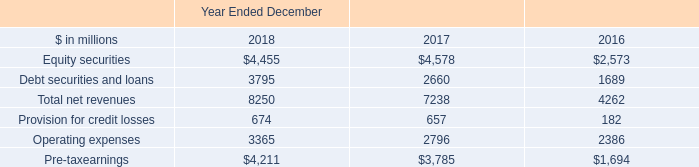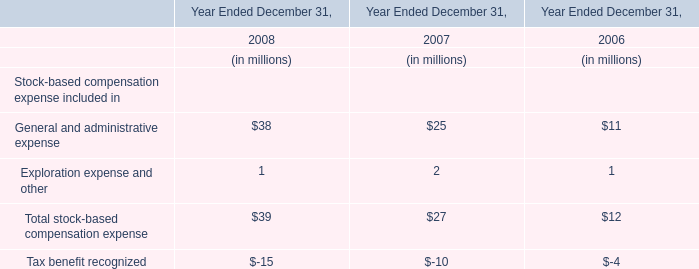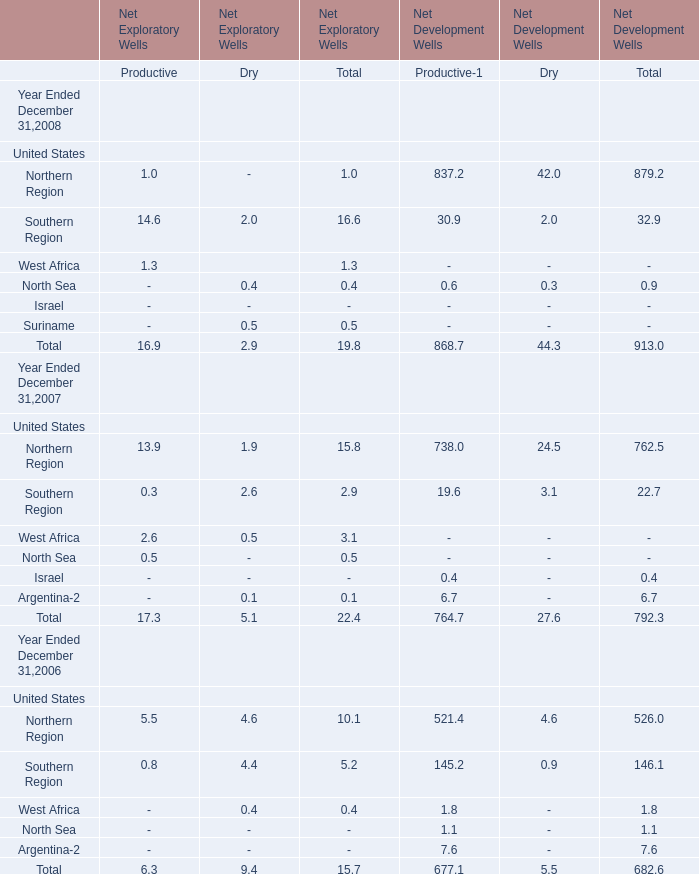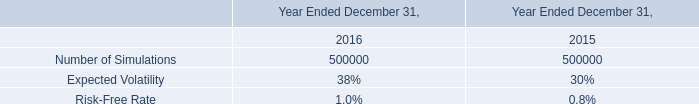What's the growth rate of Northern Region for Total of Net Development Wells in 2008? 
Computations: ((879.2 - 762.5) / 762.5)
Answer: 0.15305. 